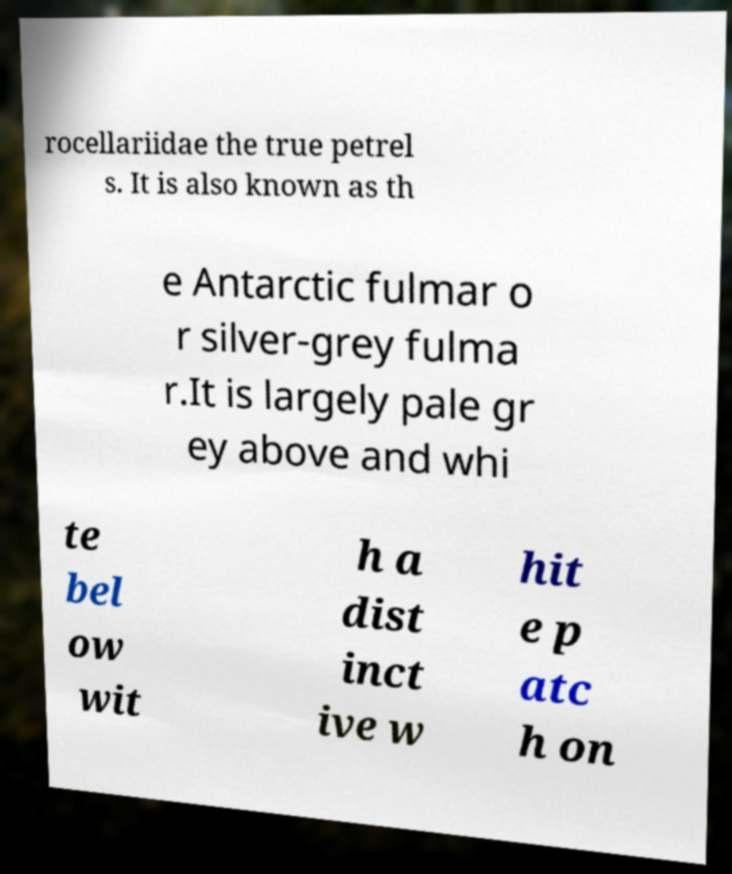Can you accurately transcribe the text from the provided image for me? rocellariidae the true petrel s. It is also known as th e Antarctic fulmar o r silver-grey fulma r.It is largely pale gr ey above and whi te bel ow wit h a dist inct ive w hit e p atc h on 